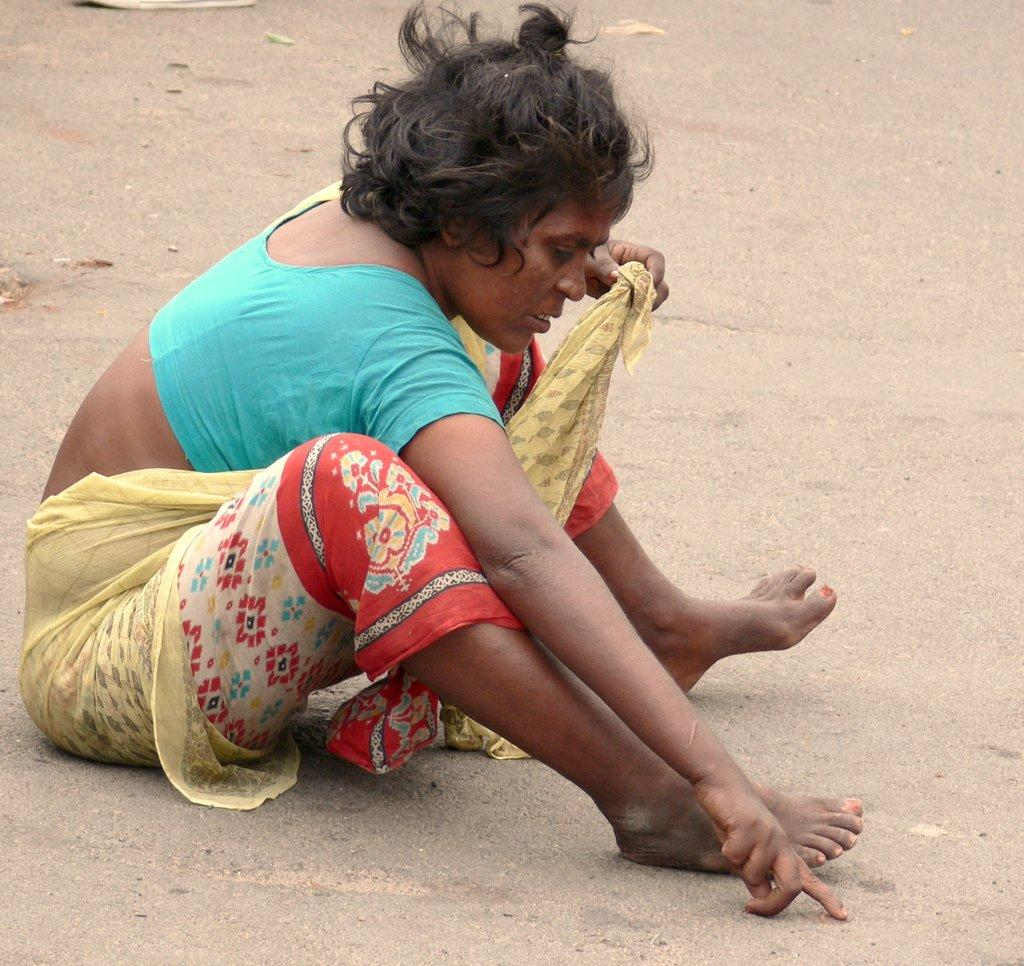Who is present in the image? There is a person in the image. What is the person wearing? The person is wearing a yellow saree. Where is the person located in the image? The person is sitting on the road. How many men are visible in the image? There is no mention of men in the image; only a person wearing a yellow saree is present. What is the height of the person in the image? The height of the person is not mentioned in the image, but we can see that they are sitting on the road. 